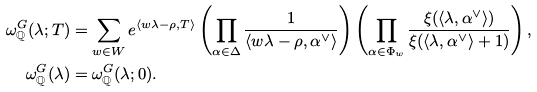Convert formula to latex. <formula><loc_0><loc_0><loc_500><loc_500>\omega ^ { G } _ { \mathbb { Q } } ( \lambda ; T ) & = \sum _ { w \in W } e ^ { \langle w \lambda - \rho , T \rangle } \left ( \prod _ { \alpha \in \Delta } \frac { 1 } { \langle w \lambda - \rho , \alpha ^ { \vee } \rangle } \right ) \left ( \prod _ { \alpha \in \Phi _ { w } } \frac { \xi ( \langle \lambda , \alpha ^ { \vee } \rangle ) } { \xi ( \langle \lambda , \alpha ^ { \vee } \rangle + 1 ) } \right ) , \\ \omega ^ { G } _ { \mathbb { Q } } ( \lambda ) & = \omega ^ { G } _ { \mathbb { Q } } ( \lambda ; 0 ) .</formula> 